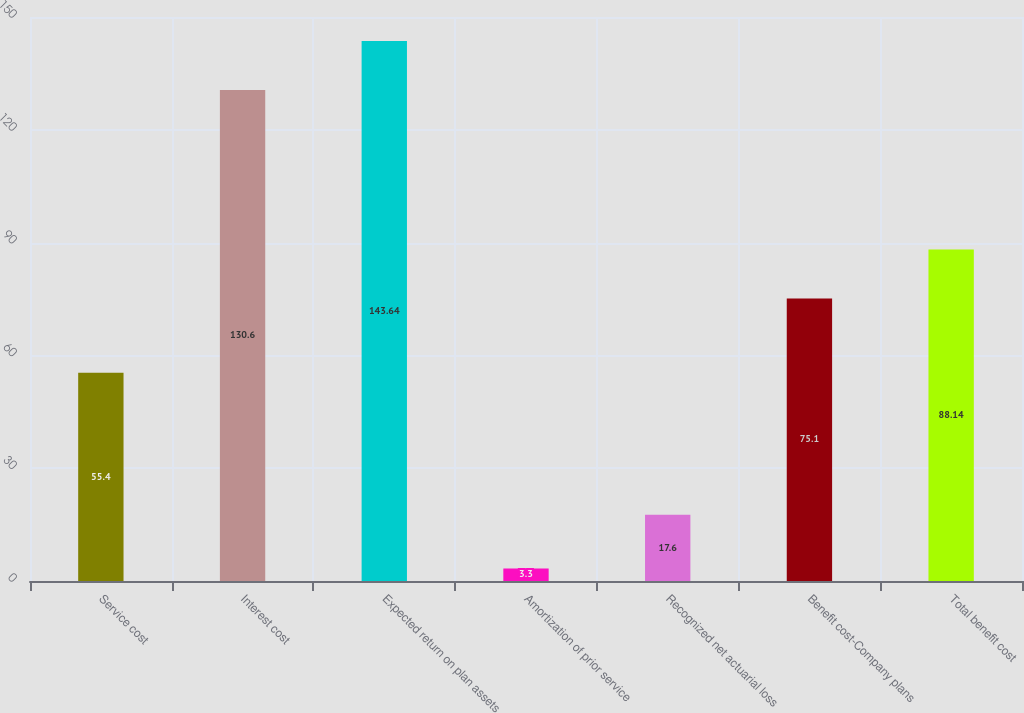<chart> <loc_0><loc_0><loc_500><loc_500><bar_chart><fcel>Service cost<fcel>Interest cost<fcel>Expected return on plan assets<fcel>Amortization of prior service<fcel>Recognized net actuarial loss<fcel>Benefit cost-Company plans<fcel>Total benefit cost<nl><fcel>55.4<fcel>130.6<fcel>143.64<fcel>3.3<fcel>17.6<fcel>75.1<fcel>88.14<nl></chart> 